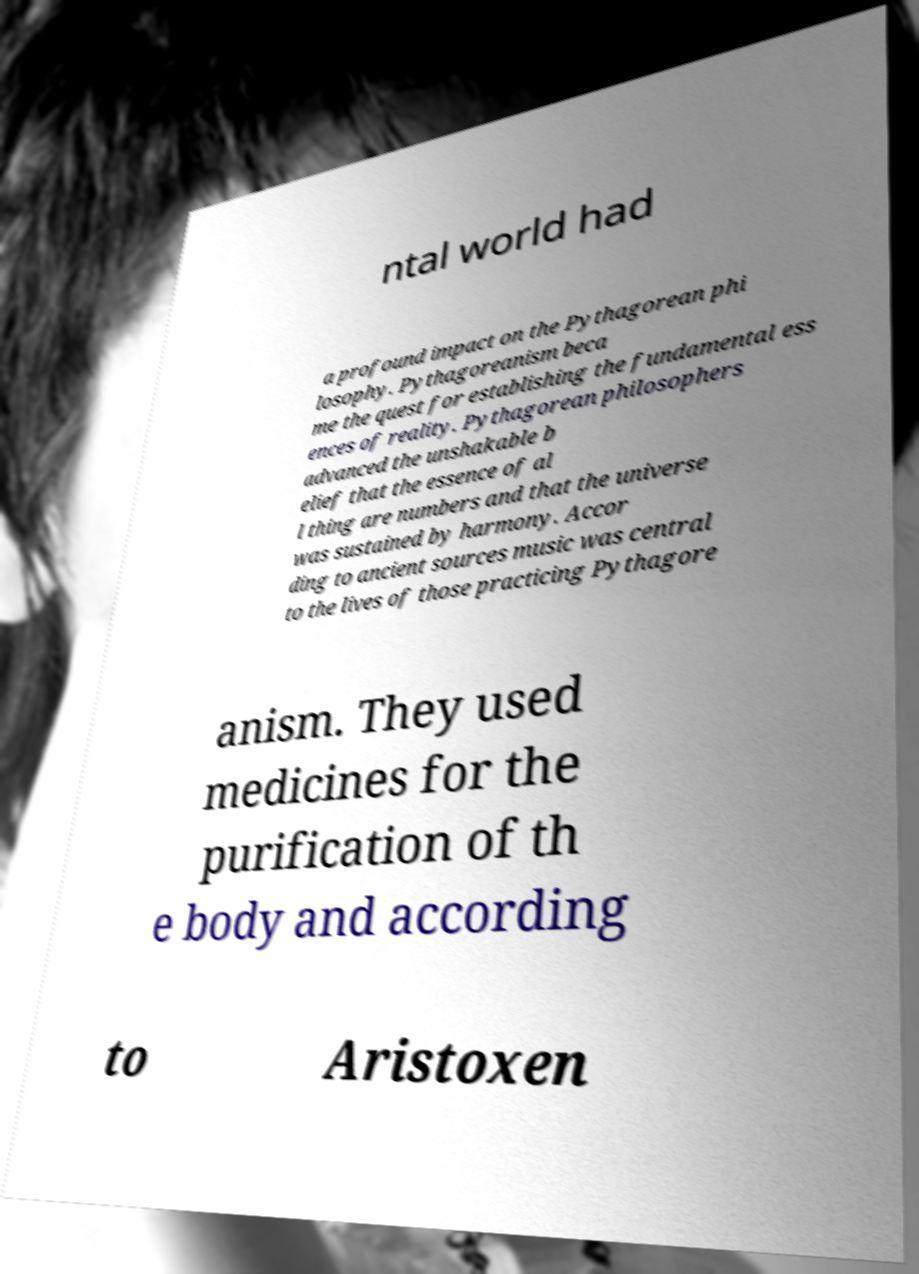Please identify and transcribe the text found in this image. ntal world had a profound impact on the Pythagorean phi losophy. Pythagoreanism beca me the quest for establishing the fundamental ess ences of reality. Pythagorean philosophers advanced the unshakable b elief that the essence of al l thing are numbers and that the universe was sustained by harmony. Accor ding to ancient sources music was central to the lives of those practicing Pythagore anism. They used medicines for the purification of th e body and according to Aristoxen 